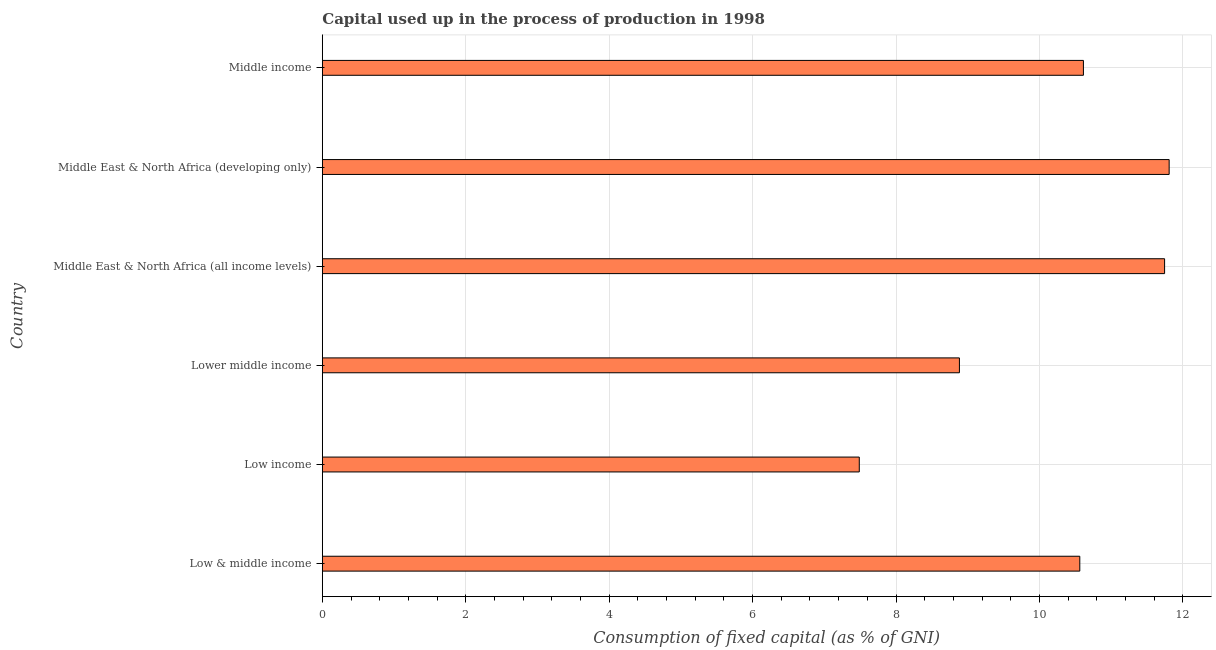Does the graph contain any zero values?
Keep it short and to the point. No. Does the graph contain grids?
Ensure brevity in your answer.  Yes. What is the title of the graph?
Your answer should be compact. Capital used up in the process of production in 1998. What is the label or title of the X-axis?
Keep it short and to the point. Consumption of fixed capital (as % of GNI). What is the label or title of the Y-axis?
Keep it short and to the point. Country. What is the consumption of fixed capital in Middle income?
Provide a short and direct response. 10.61. Across all countries, what is the maximum consumption of fixed capital?
Offer a terse response. 11.81. Across all countries, what is the minimum consumption of fixed capital?
Provide a short and direct response. 7.49. In which country was the consumption of fixed capital maximum?
Offer a terse response. Middle East & North Africa (developing only). What is the sum of the consumption of fixed capital?
Provide a short and direct response. 61.1. What is the difference between the consumption of fixed capital in Low & middle income and Low income?
Your response must be concise. 3.08. What is the average consumption of fixed capital per country?
Offer a terse response. 10.18. What is the median consumption of fixed capital?
Keep it short and to the point. 10.59. In how many countries, is the consumption of fixed capital greater than 1.6 %?
Keep it short and to the point. 6. What is the ratio of the consumption of fixed capital in Lower middle income to that in Middle East & North Africa (all income levels)?
Your response must be concise. 0.76. Is the consumption of fixed capital in Low & middle income less than that in Low income?
Your answer should be compact. No. What is the difference between the highest and the second highest consumption of fixed capital?
Your answer should be very brief. 0.06. What is the difference between the highest and the lowest consumption of fixed capital?
Keep it short and to the point. 4.32. In how many countries, is the consumption of fixed capital greater than the average consumption of fixed capital taken over all countries?
Provide a short and direct response. 4. Are the values on the major ticks of X-axis written in scientific E-notation?
Offer a very short reply. No. What is the Consumption of fixed capital (as % of GNI) in Low & middle income?
Provide a short and direct response. 10.56. What is the Consumption of fixed capital (as % of GNI) in Low income?
Offer a very short reply. 7.49. What is the Consumption of fixed capital (as % of GNI) of Lower middle income?
Provide a short and direct response. 8.88. What is the Consumption of fixed capital (as % of GNI) of Middle East & North Africa (all income levels)?
Your response must be concise. 11.75. What is the Consumption of fixed capital (as % of GNI) of Middle East & North Africa (developing only)?
Keep it short and to the point. 11.81. What is the Consumption of fixed capital (as % of GNI) of Middle income?
Make the answer very short. 10.61. What is the difference between the Consumption of fixed capital (as % of GNI) in Low & middle income and Low income?
Provide a succinct answer. 3.08. What is the difference between the Consumption of fixed capital (as % of GNI) in Low & middle income and Lower middle income?
Your answer should be compact. 1.68. What is the difference between the Consumption of fixed capital (as % of GNI) in Low & middle income and Middle East & North Africa (all income levels)?
Offer a very short reply. -1.18. What is the difference between the Consumption of fixed capital (as % of GNI) in Low & middle income and Middle East & North Africa (developing only)?
Provide a succinct answer. -1.25. What is the difference between the Consumption of fixed capital (as % of GNI) in Low & middle income and Middle income?
Provide a succinct answer. -0.05. What is the difference between the Consumption of fixed capital (as % of GNI) in Low income and Lower middle income?
Keep it short and to the point. -1.4. What is the difference between the Consumption of fixed capital (as % of GNI) in Low income and Middle East & North Africa (all income levels)?
Offer a terse response. -4.26. What is the difference between the Consumption of fixed capital (as % of GNI) in Low income and Middle East & North Africa (developing only)?
Keep it short and to the point. -4.32. What is the difference between the Consumption of fixed capital (as % of GNI) in Low income and Middle income?
Keep it short and to the point. -3.13. What is the difference between the Consumption of fixed capital (as % of GNI) in Lower middle income and Middle East & North Africa (all income levels)?
Give a very brief answer. -2.86. What is the difference between the Consumption of fixed capital (as % of GNI) in Lower middle income and Middle East & North Africa (developing only)?
Give a very brief answer. -2.92. What is the difference between the Consumption of fixed capital (as % of GNI) in Lower middle income and Middle income?
Provide a short and direct response. -1.73. What is the difference between the Consumption of fixed capital (as % of GNI) in Middle East & North Africa (all income levels) and Middle East & North Africa (developing only)?
Keep it short and to the point. -0.06. What is the difference between the Consumption of fixed capital (as % of GNI) in Middle East & North Africa (all income levels) and Middle income?
Your answer should be very brief. 1.13. What is the difference between the Consumption of fixed capital (as % of GNI) in Middle East & North Africa (developing only) and Middle income?
Ensure brevity in your answer.  1.2. What is the ratio of the Consumption of fixed capital (as % of GNI) in Low & middle income to that in Low income?
Give a very brief answer. 1.41. What is the ratio of the Consumption of fixed capital (as % of GNI) in Low & middle income to that in Lower middle income?
Provide a short and direct response. 1.19. What is the ratio of the Consumption of fixed capital (as % of GNI) in Low & middle income to that in Middle East & North Africa (all income levels)?
Make the answer very short. 0.9. What is the ratio of the Consumption of fixed capital (as % of GNI) in Low & middle income to that in Middle East & North Africa (developing only)?
Your answer should be compact. 0.89. What is the ratio of the Consumption of fixed capital (as % of GNI) in Low income to that in Lower middle income?
Your answer should be compact. 0.84. What is the ratio of the Consumption of fixed capital (as % of GNI) in Low income to that in Middle East & North Africa (all income levels)?
Give a very brief answer. 0.64. What is the ratio of the Consumption of fixed capital (as % of GNI) in Low income to that in Middle East & North Africa (developing only)?
Your response must be concise. 0.63. What is the ratio of the Consumption of fixed capital (as % of GNI) in Low income to that in Middle income?
Provide a short and direct response. 0.7. What is the ratio of the Consumption of fixed capital (as % of GNI) in Lower middle income to that in Middle East & North Africa (all income levels)?
Provide a succinct answer. 0.76. What is the ratio of the Consumption of fixed capital (as % of GNI) in Lower middle income to that in Middle East & North Africa (developing only)?
Offer a very short reply. 0.75. What is the ratio of the Consumption of fixed capital (as % of GNI) in Lower middle income to that in Middle income?
Keep it short and to the point. 0.84. What is the ratio of the Consumption of fixed capital (as % of GNI) in Middle East & North Africa (all income levels) to that in Middle East & North Africa (developing only)?
Your response must be concise. 0.99. What is the ratio of the Consumption of fixed capital (as % of GNI) in Middle East & North Africa (all income levels) to that in Middle income?
Your response must be concise. 1.11. What is the ratio of the Consumption of fixed capital (as % of GNI) in Middle East & North Africa (developing only) to that in Middle income?
Provide a short and direct response. 1.11. 